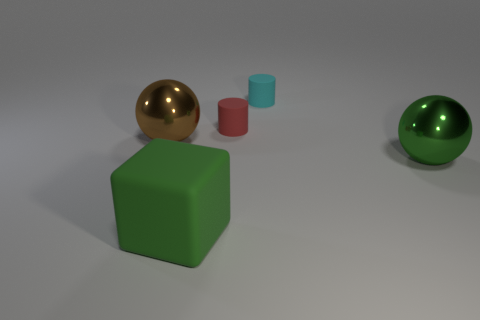Add 5 big yellow rubber cylinders. How many objects exist? 10 Subtract all cylinders. How many objects are left? 3 Subtract all cyan things. Subtract all gray cubes. How many objects are left? 4 Add 5 red matte objects. How many red matte objects are left? 6 Add 5 brown balls. How many brown balls exist? 6 Subtract 0 green cylinders. How many objects are left? 5 